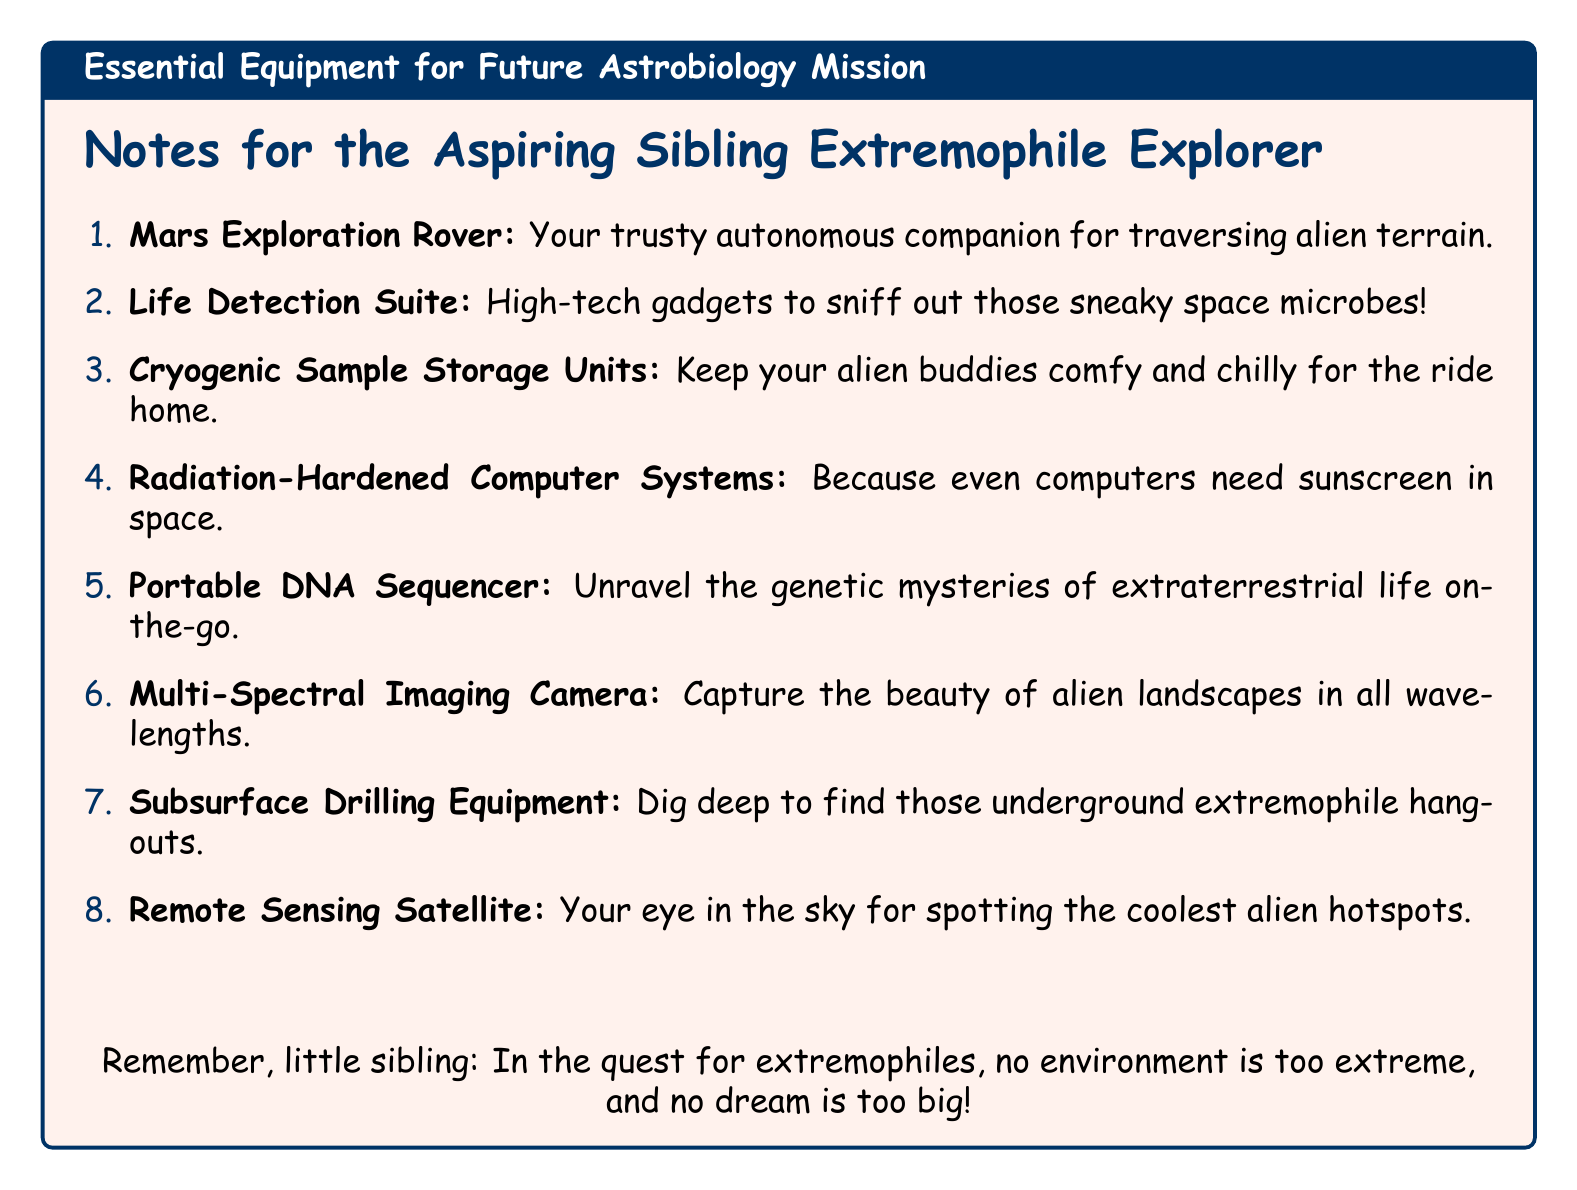What is the first item listed in the essential equipment? The first item listed is the Mars Exploration Rover, which is designed for traversing the Martian surface.
Answer: Mars Exploration Rover What is the purpose of the Life Detection Suite? The Life Detection Suite is designed to detect and analyze potential biosignatures in extreme environments.
Answer: Detect and analyze biosignatures How many essential equipment items are listed in total? There are eight items listed in the essential equipment section of the document.
Answer: Eight What type of samples do Cryogenic Sample Storage Units preserve? The Cryogenic Sample Storage Units preserve collected samples at extremely low temperatures.
Answer: Collected samples What is the function of the Remote Sensing Satellite? The Remote Sensing Satellite identifies potential landing sites and areas of scientific interest from space.
Answer: Identify landing sites What is necessary for a Portable DNA Sequencer? A Portable DNA Sequencer is necessary for analyzing genetic material in the field to study potential extremophiles.
Answer: Analyzing genetic material Why is equipment radiation-hardened? Radiation-Hardened Computer Systems are designed to withstand the harsh radiation environment of space.
Answer: To withstand radiation What technology helps capture images across various wavelengths? The Multi-Spectral Imaging Camera captures images across various wavelengths, aiding in identifying potential habitats.
Answer: Multi-Spectral Imaging Camera 